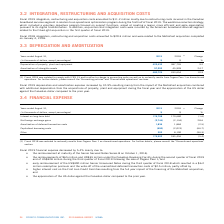According to Cogeco's financial document, What was the reimbursement amount under the Canadian Revolving Facility during the second quarter of 2019? $65 million and US$35 million. The document states: "• the reimbursements of $65 million and US$35 million under the Canadian Revolving Facility during the second quarter of fiscal 2019 and of US$328 mil..." Also, What was the early reimbursement amount of Senior Unsecured Notes in the third quarter of 2018? According to the financial document, US$400 million. The relevant text states: "• early reimbursement of the US$400 million Senior Unsecured Notes during the third quarter of fiscal 2018 which resulted in a $6.2 million red..." Also, What was the redemption premium in third quarter of 2018? $6.2 million redemption premium. The document states: "e third quarter of fiscal 2018 which resulted in a $6.2 million redemption premium and the write-off of the unamortized deferred transaction costs of ..." Also, can you calculate: What was the increase / (decrease) in the interest on long-term debt from 2018 to 2019? Based on the calculation: 176,798 - 179,680, the result is -2882 (in thousands). This is based on the information: "Interest on long-term debt 176,798 179,680 (1.6) Interest on long-term debt 176,798 179,680 (1.6)..." The key data points involved are: 176,798, 179,680. Also, can you calculate: What was the average net foreign exchange gains between 2018 and 2019? To answer this question, I need to perform calculations using the financial data. The calculation is: - (2,744 + 2,134) / 2, which equals -2439 (in thousands). This is based on the information: "Net foreign exchange gains (2,744) (2,134) 28.6 Net foreign exchange gains (2,744) (2,134) 28.6..." The key data points involved are: 2,134, 2,744. Also, can you calculate: What was the increase / (decrease) in the amortization of deferred transactions costs from 2018 to 2019? Based on the calculation: 1,836 - 1,884, the result is -48 (in thousands). This is based on the information: "Amortization of deferred transaction costs 1,836 1,884 (2.5) Amortization of deferred transaction costs 1,836 1,884 (2.5)..." The key data points involved are: 1,836, 1,884. 